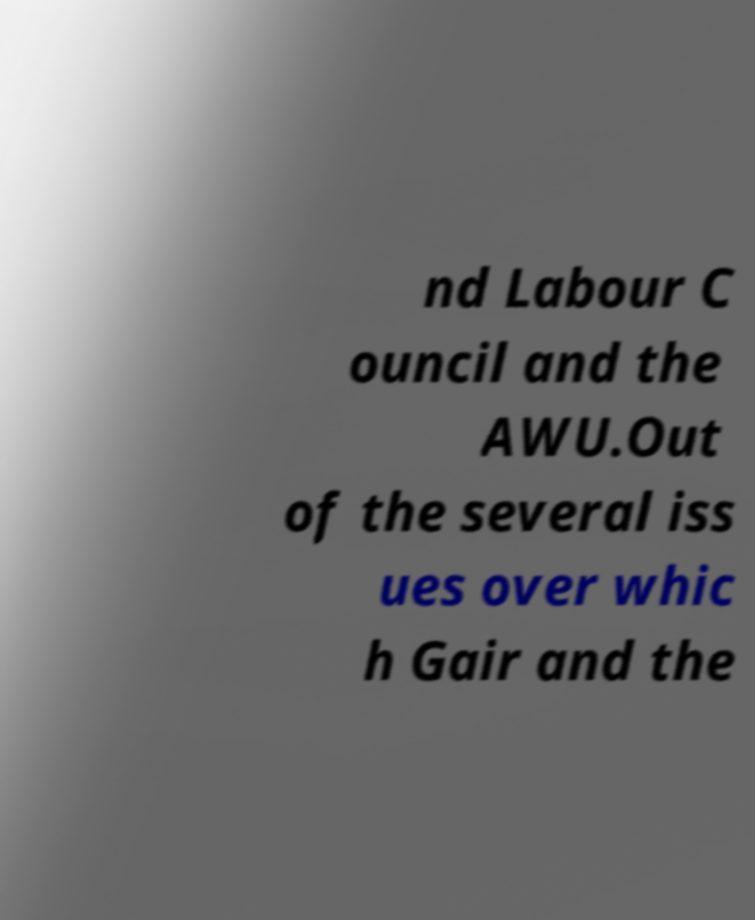Please identify and transcribe the text found in this image. nd Labour C ouncil and the AWU.Out of the several iss ues over whic h Gair and the 